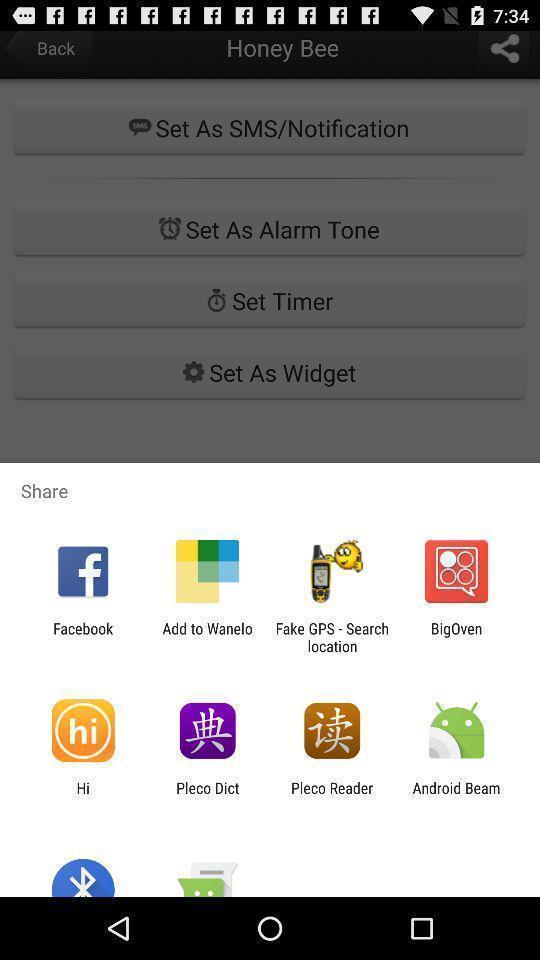Explain the elements present in this screenshot. Pop up with various social apps. 